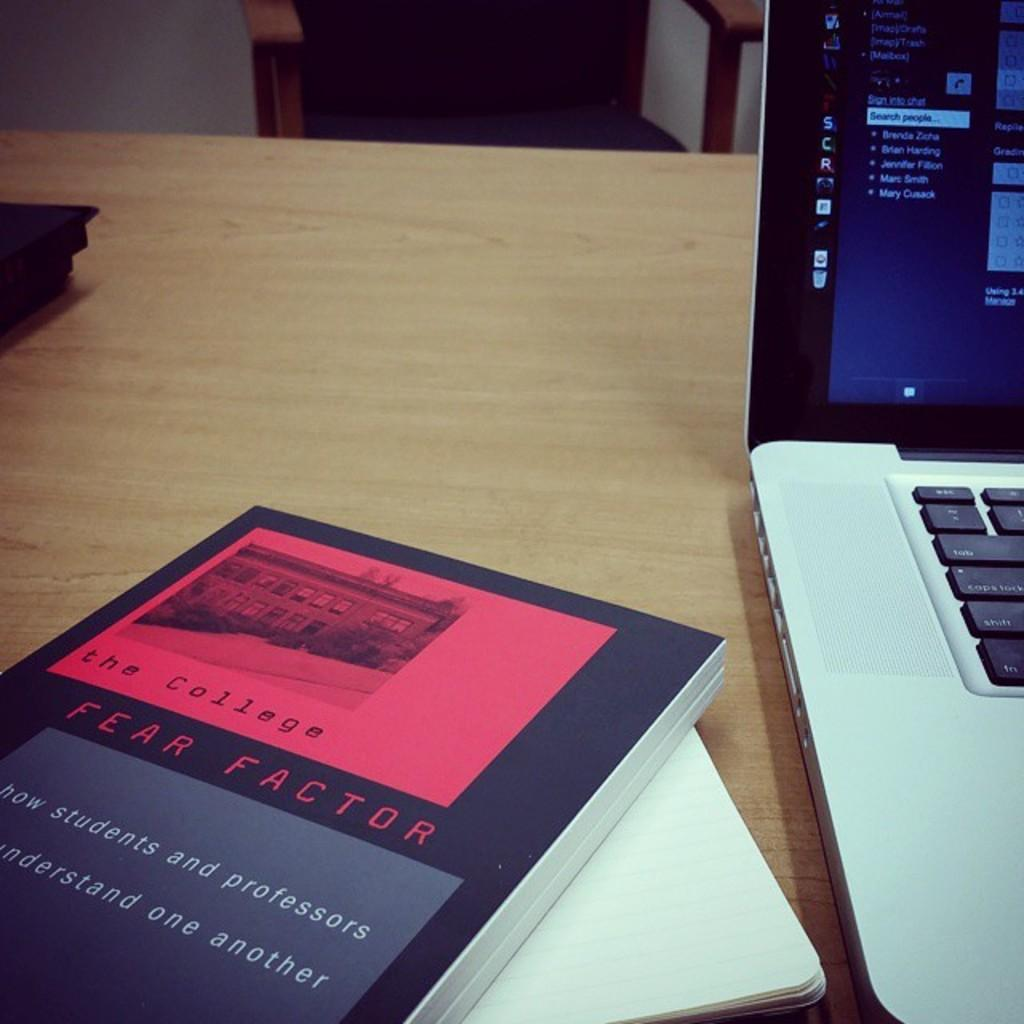Provide a one-sentence caption for the provided image. The book beside the computer is titled Fear Factor. 